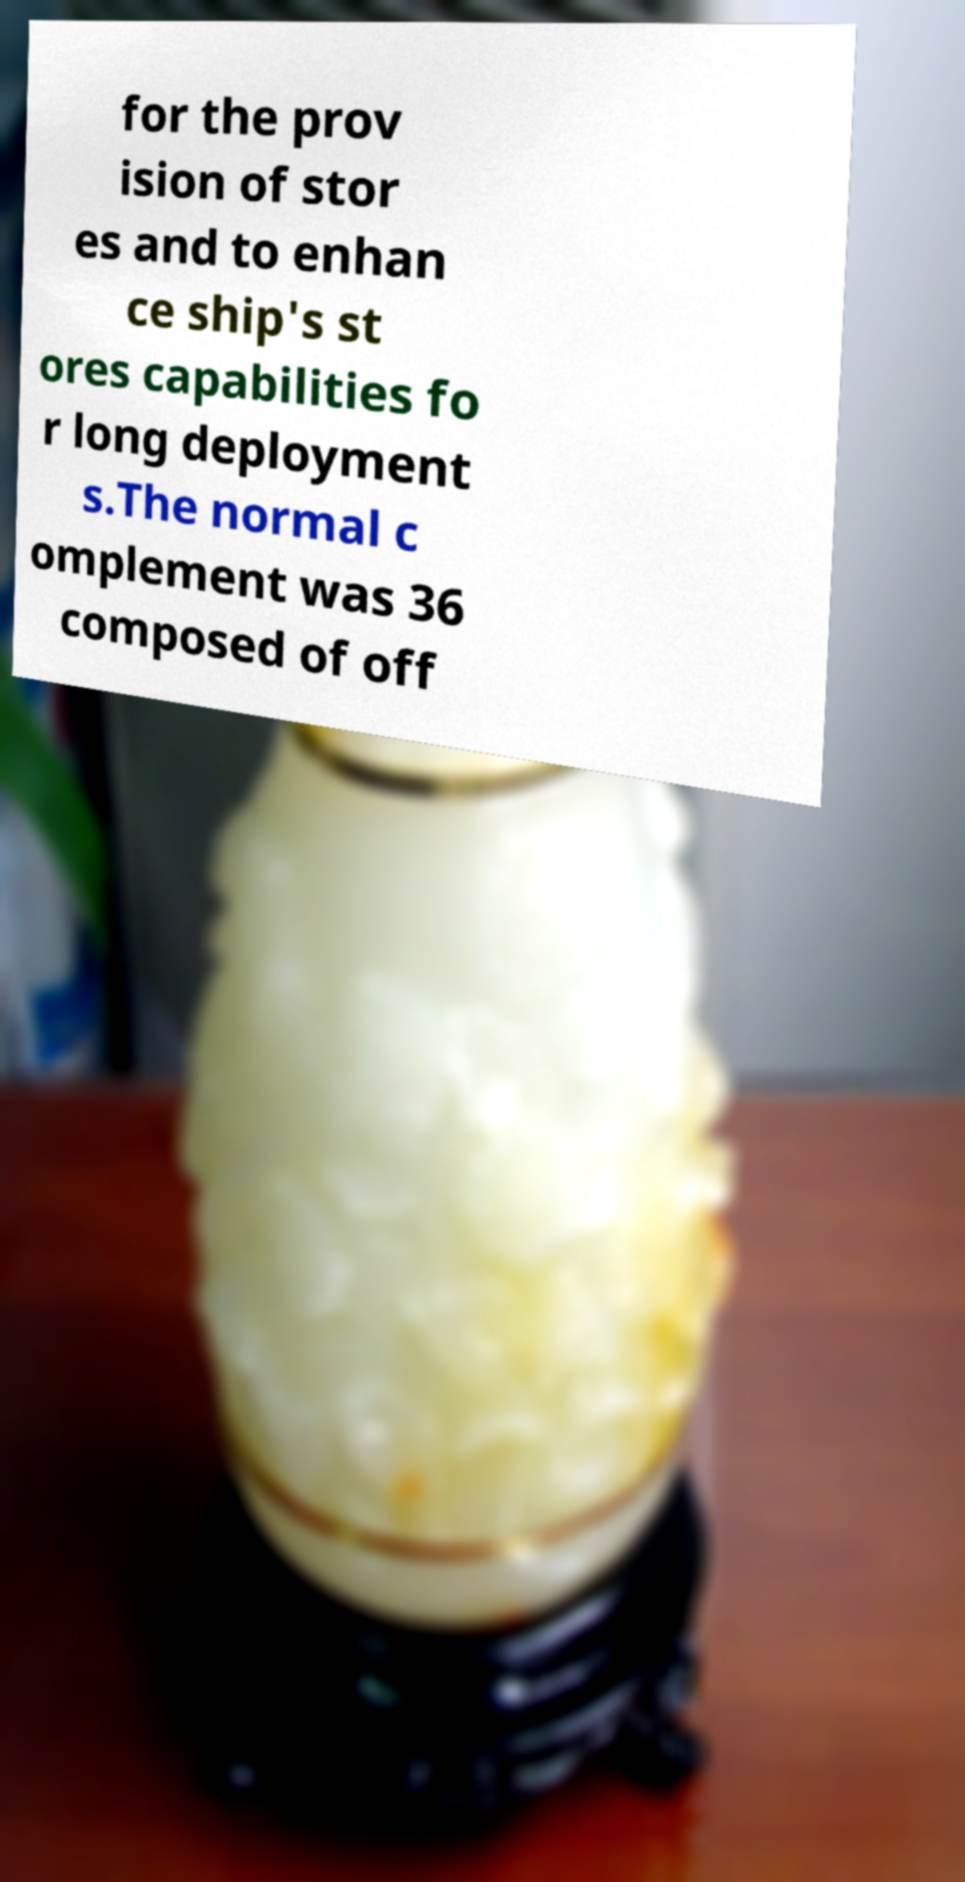What messages or text are displayed in this image? I need them in a readable, typed format. for the prov ision of stor es and to enhan ce ship's st ores capabilities fo r long deployment s.The normal c omplement was 36 composed of off 